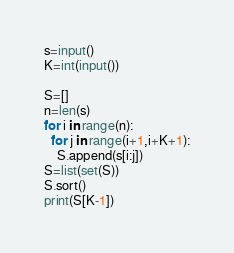Convert code to text. <code><loc_0><loc_0><loc_500><loc_500><_Python_>s=input()
K=int(input())

S=[]
n=len(s)
for i in range(n):
  for j in range(i+1,i+K+1):
    S.append(s[i:j])
S=list(set(S))
S.sort()
print(S[K-1])</code> 